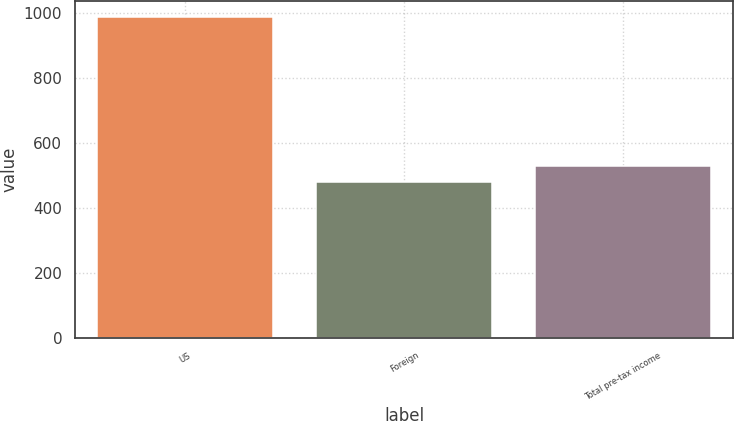Convert chart. <chart><loc_0><loc_0><loc_500><loc_500><bar_chart><fcel>US<fcel>Foreign<fcel>Total pre-tax income<nl><fcel>987<fcel>478<fcel>528.9<nl></chart> 